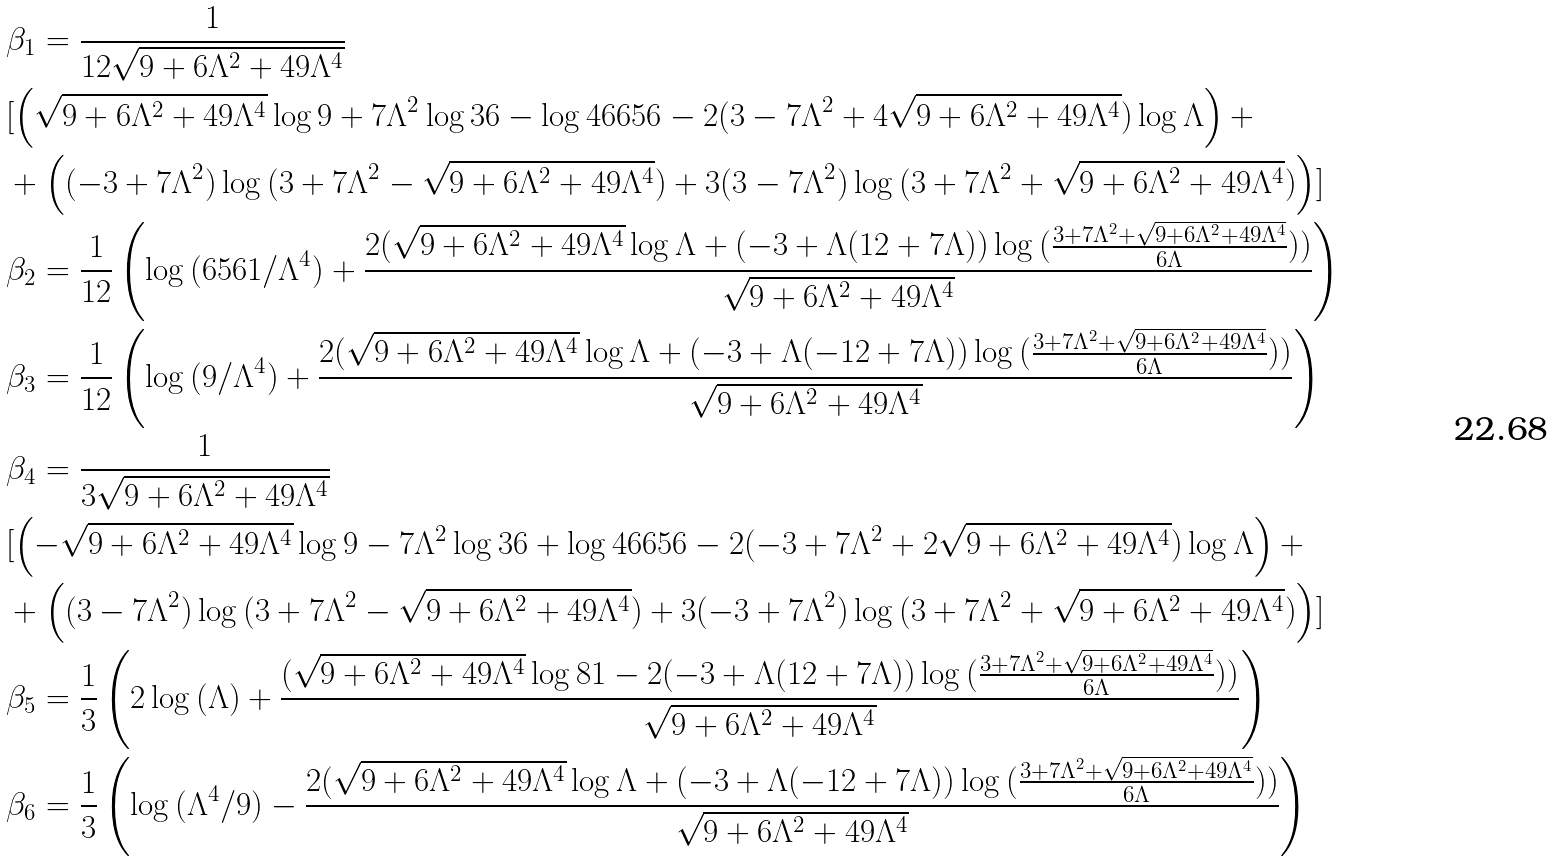Convert formula to latex. <formula><loc_0><loc_0><loc_500><loc_500>& \beta _ { 1 } = \frac { 1 } { 1 2 \sqrt { 9 + 6 \Lambda ^ { 2 } + 4 9 \Lambda ^ { 4 } } } \\ & [ \left ( \sqrt { 9 + 6 \Lambda ^ { 2 } + 4 9 \Lambda ^ { 4 } } \log { 9 } + 7 \Lambda ^ { 2 } \log { 3 6 } - \log { 4 6 6 5 6 } - 2 ( 3 - 7 \Lambda ^ { 2 } + 4 \sqrt { 9 + 6 \Lambda ^ { 2 } + 4 9 \Lambda ^ { 4 } } ) \log { \Lambda } \right ) + \\ & + \left ( ( - 3 + 7 \Lambda ^ { 2 } ) \log { ( 3 + 7 \Lambda ^ { 2 } - \sqrt { 9 + 6 \Lambda ^ { 2 } + 4 9 \Lambda ^ { 4 } } ) } + 3 ( 3 - 7 \Lambda ^ { 2 } ) \log { ( 3 + 7 \Lambda ^ { 2 } + \sqrt { 9 + 6 \Lambda ^ { 2 } + 4 9 \Lambda ^ { 4 } } ) } \right ) ] \\ & \beta _ { 2 } = \frac { 1 } { 1 2 } \left ( \log { ( 6 5 6 1 / \Lambda ^ { 4 } ) } + \frac { 2 ( \sqrt { 9 + 6 \Lambda ^ { 2 } + 4 9 \Lambda ^ { 4 } } \log { \Lambda } + ( - 3 + \Lambda ( 1 2 + 7 \Lambda ) ) \log { ( \frac { 3 + 7 \Lambda ^ { 2 } + \sqrt { 9 + 6 \Lambda ^ { 2 } + 4 9 \Lambda ^ { 4 } } } { 6 \Lambda } ) } ) } { \sqrt { 9 + 6 \Lambda ^ { 2 } + 4 9 \Lambda ^ { 4 } } } \right ) \\ & \beta _ { 3 } = \frac { 1 } { 1 2 } \left ( \log { ( 9 / \Lambda ^ { 4 } ) } + \frac { 2 ( \sqrt { 9 + 6 \Lambda ^ { 2 } + 4 9 \Lambda ^ { 4 } } \log { \Lambda } + ( - 3 + \Lambda ( - 1 2 + 7 \Lambda ) ) \log { ( \frac { 3 + 7 \Lambda ^ { 2 } + \sqrt { 9 + 6 \Lambda ^ { 2 } + 4 9 \Lambda ^ { 4 } } } { 6 \Lambda } ) } ) } { \sqrt { 9 + 6 \Lambda ^ { 2 } + 4 9 \Lambda ^ { 4 } } } \right ) \\ & \beta _ { 4 } = \frac { 1 } { 3 \sqrt { 9 + 6 \Lambda ^ { 2 } + 4 9 \Lambda ^ { 4 } } } \\ & [ \left ( - \sqrt { 9 + 6 \Lambda ^ { 2 } + 4 9 \Lambda ^ { 4 } } \log { 9 } - 7 \Lambda ^ { 2 } \log { 3 6 } + \log { 4 6 6 5 6 } - 2 ( - 3 + 7 \Lambda ^ { 2 } + 2 \sqrt { 9 + 6 \Lambda ^ { 2 } + 4 9 \Lambda ^ { 4 } } ) \log { \Lambda } \right ) + \\ & + \left ( ( 3 - 7 \Lambda ^ { 2 } ) \log { ( 3 + 7 \Lambda ^ { 2 } - \sqrt { 9 + 6 \Lambda ^ { 2 } + 4 9 \Lambda ^ { 4 } } ) } + 3 ( - 3 + 7 \Lambda ^ { 2 } ) \log { ( 3 + 7 \Lambda ^ { 2 } + \sqrt { 9 + 6 \Lambda ^ { 2 } + 4 9 \Lambda ^ { 4 } } ) } \right ) ] \\ & \beta _ { 5 } = \frac { 1 } { 3 } \left ( 2 \log { ( \Lambda ) } + \frac { ( \sqrt { 9 + 6 \Lambda ^ { 2 } + 4 9 \Lambda ^ { 4 } } \log { 8 1 } - 2 ( - 3 + \Lambda ( 1 2 + 7 \Lambda ) ) \log { ( \frac { 3 + 7 \Lambda ^ { 2 } + \sqrt { 9 + 6 \Lambda ^ { 2 } + 4 9 \Lambda ^ { 4 } } } { 6 \Lambda } ) } ) } { \sqrt { 9 + 6 \Lambda ^ { 2 } + 4 9 \Lambda ^ { 4 } } } \right ) \\ & \beta _ { 6 } = \frac { 1 } { 3 } \left ( \log { ( \Lambda ^ { 4 } / 9 ) } - \frac { 2 ( \sqrt { 9 + 6 \Lambda ^ { 2 } + 4 9 \Lambda ^ { 4 } } \log { \Lambda } + ( - 3 + \Lambda ( - 1 2 + 7 \Lambda ) ) \log { ( \frac { 3 + 7 \Lambda ^ { 2 } + \sqrt { 9 + 6 \Lambda ^ { 2 } + 4 9 \Lambda ^ { 4 } } } { 6 \Lambda } ) } ) } { \sqrt { 9 + 6 \Lambda ^ { 2 } + 4 9 \Lambda ^ { 4 } } } \right )</formula> 